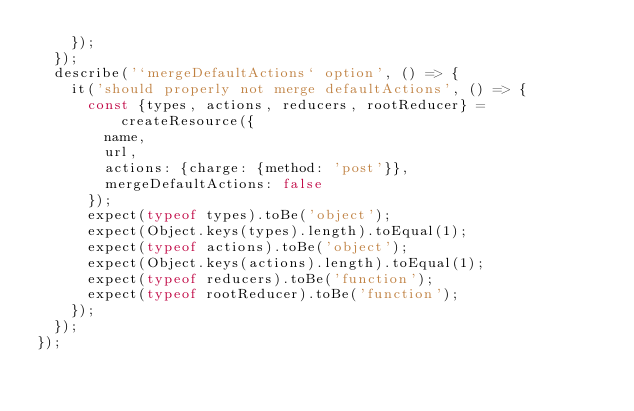Convert code to text. <code><loc_0><loc_0><loc_500><loc_500><_JavaScript_>    });
  });
  describe('`mergeDefaultActions` option', () => {
    it('should properly not merge defaultActions', () => {
      const {types, actions, reducers, rootReducer} = createResource({
        name,
        url,
        actions: {charge: {method: 'post'}},
        mergeDefaultActions: false
      });
      expect(typeof types).toBe('object');
      expect(Object.keys(types).length).toEqual(1);
      expect(typeof actions).toBe('object');
      expect(Object.keys(actions).length).toEqual(1);
      expect(typeof reducers).toBe('function');
      expect(typeof rootReducer).toBe('function');
    });
  });
});
</code> 